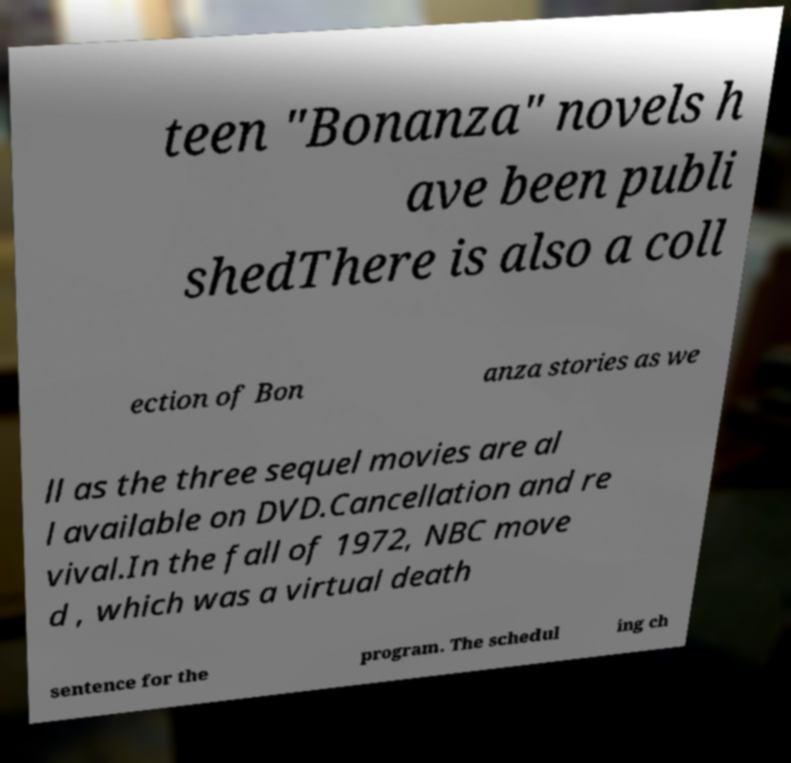There's text embedded in this image that I need extracted. Can you transcribe it verbatim? teen "Bonanza" novels h ave been publi shedThere is also a coll ection of Bon anza stories as we ll as the three sequel movies are al l available on DVD.Cancellation and re vival.In the fall of 1972, NBC move d , which was a virtual death sentence for the program. The schedul ing ch 